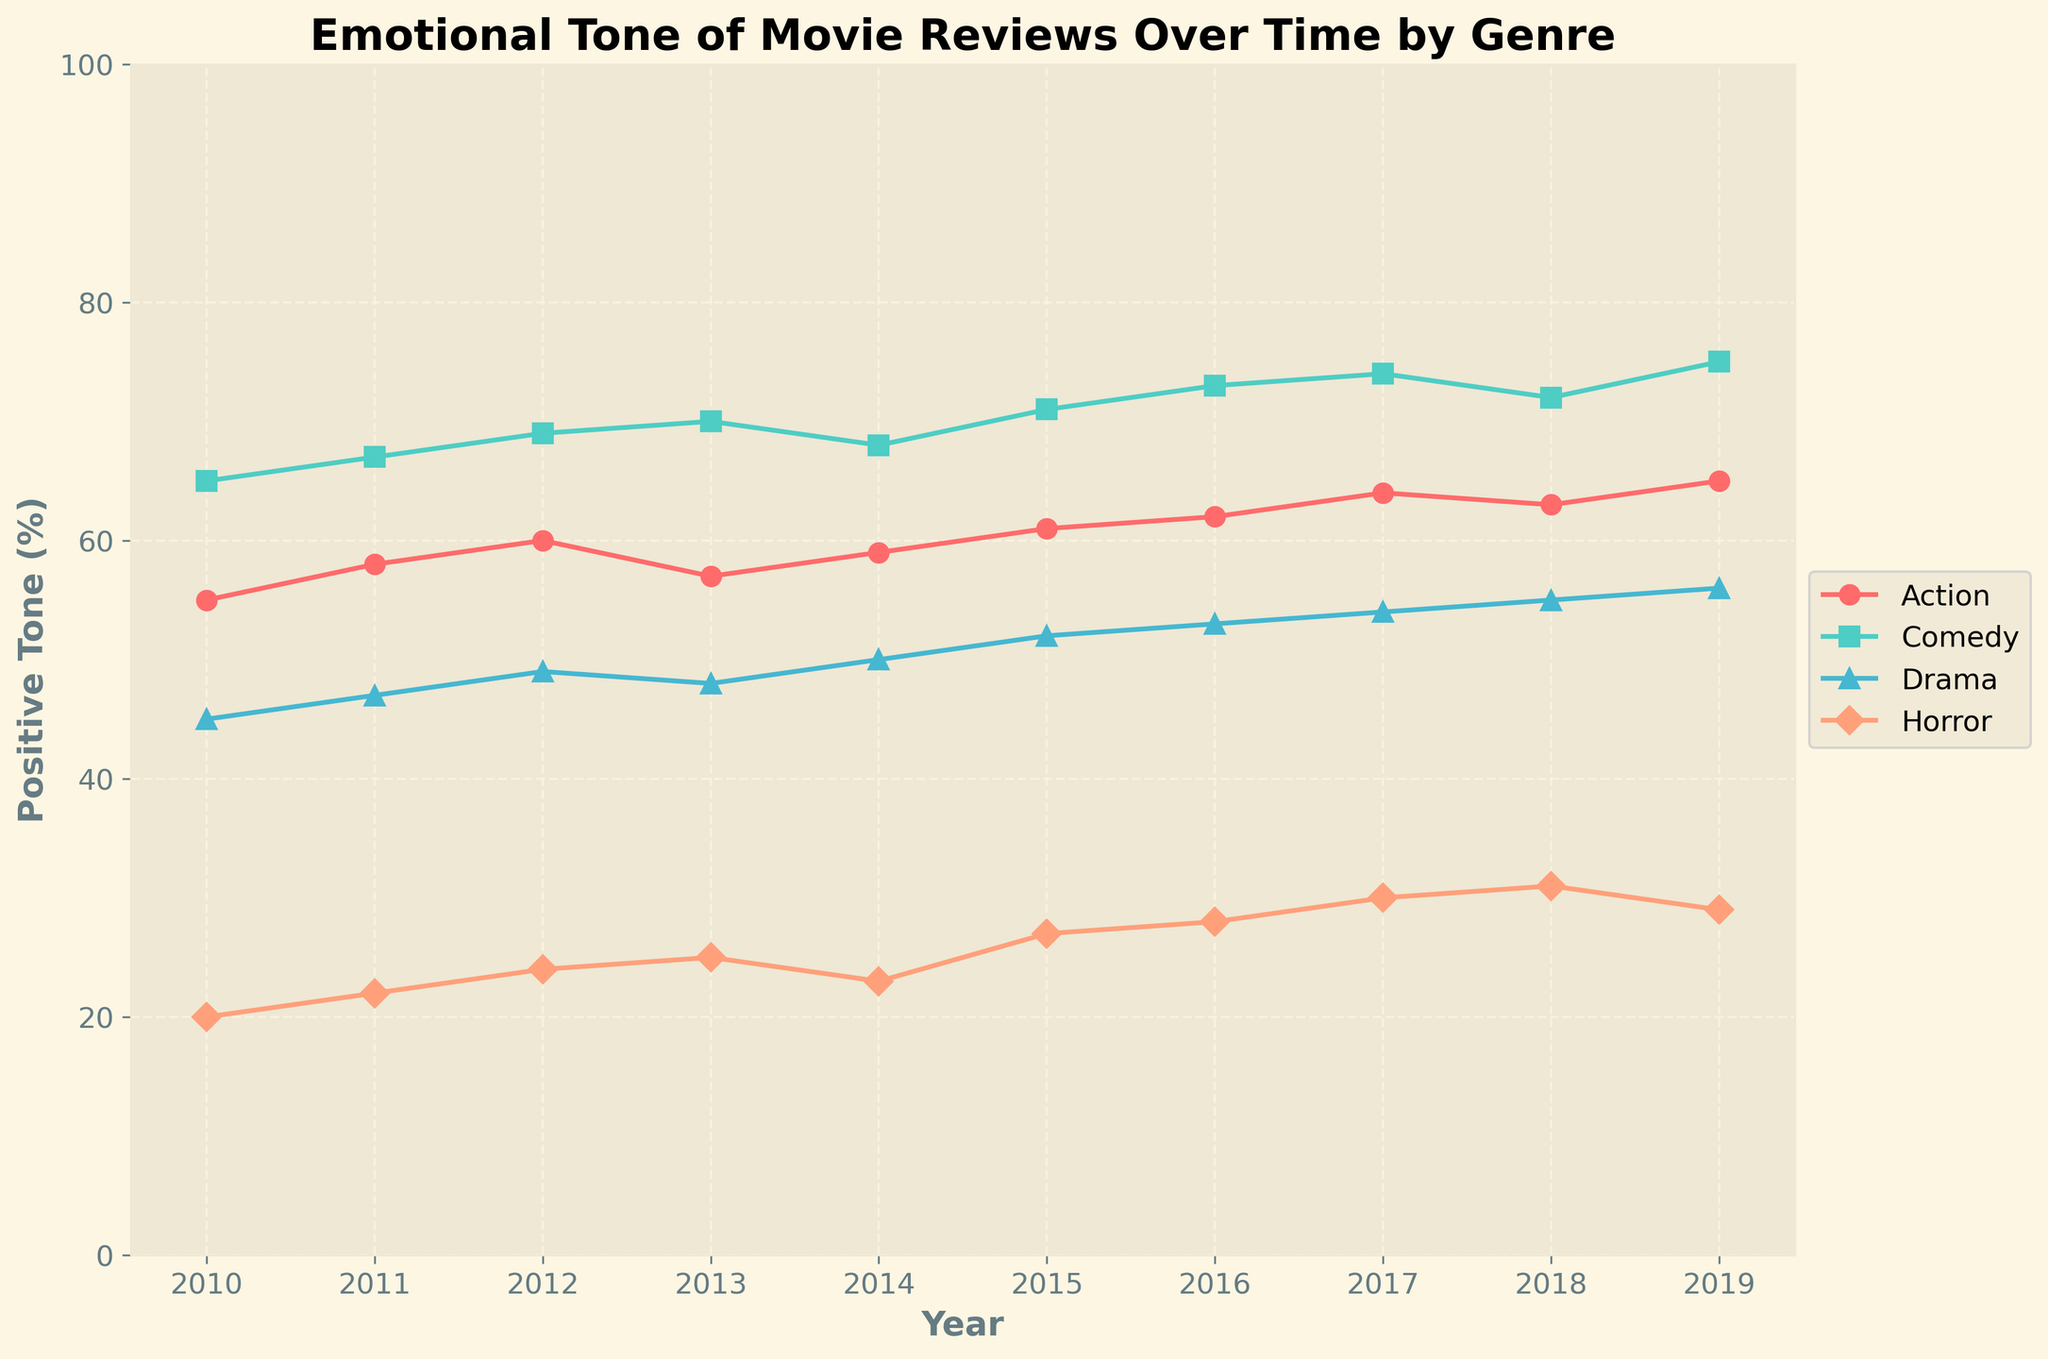What's the title of the plot? The title is usually placed at the top center of the plot, and it's written large and bold to stand out.
Answer: Emotional Tone of Movie Reviews Over Time by Genre Which genre has the highest positive tone for the year 2019? Look along the 2019 x-tick on the x-axis and find the data point that is the highest among the genres.
Answer: Comedy What is the overall trend in positive tone for the Horror genre from 2010 to 2019? Track the data points representing the Horror genre (usually identified by the legend) from the start at 2010 to the end at 2019 on the plot and note the change in values.
Answer: Increasing Which genre shows the greatest increase in positive tone from 2010 to 2019? For each genre, subtract the 2010 value from the 2019 value and identify which difference is the largest.
Answer: Comedy By how much did the positive tone for Drama change from 2015 to 2017? Find the positive tone values for Drama at 2015 and 2017 and calculate their difference.
Answer: +2% Compare the positive tone of Action and Drama genres in 2016. Which had a higher value? Locate the data points for both Action and Drama in the year 2016 and see which one is higher vertically.
Answer: Drama What's the average positive tone of Comedy from 2010 to 2019? Sum up all the positive tone values for Comedy from 2010 to 2019 and divide by the number of years (10).
Answer: 70 How does the variability of positive tone for Action compare to Horror across the years? Look at the fluctuation (gaps between highest and lowest points) for Action and Horror lines on the plot and compare.
Answer: Action has more variability than Horror During which year did Comedy reach its highest positive tone? Identify the peak point on the Comedy line and note the corresponding year on the x-axis.
Answer: 2019 What is the difference in positive tone between Comedy and Horror in 2012? Find the positive tone values for Comedy and Horror in 2012, then calculate Comedy's value minus Horror's value.
Answer: 45 